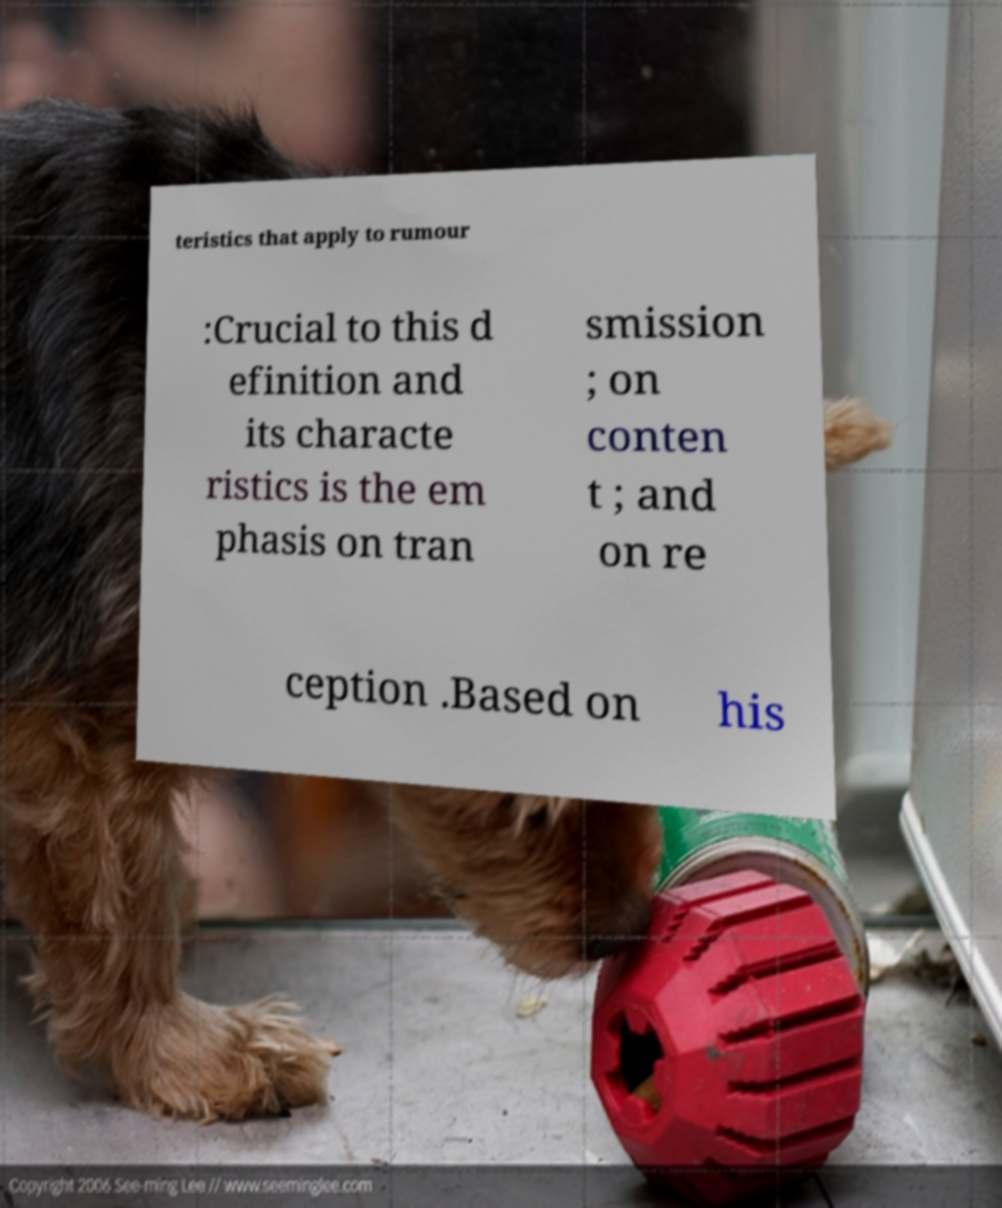Please read and relay the text visible in this image. What does it say? teristics that apply to rumour :Crucial to this d efinition and its characte ristics is the em phasis on tran smission ; on conten t ; and on re ception .Based on his 